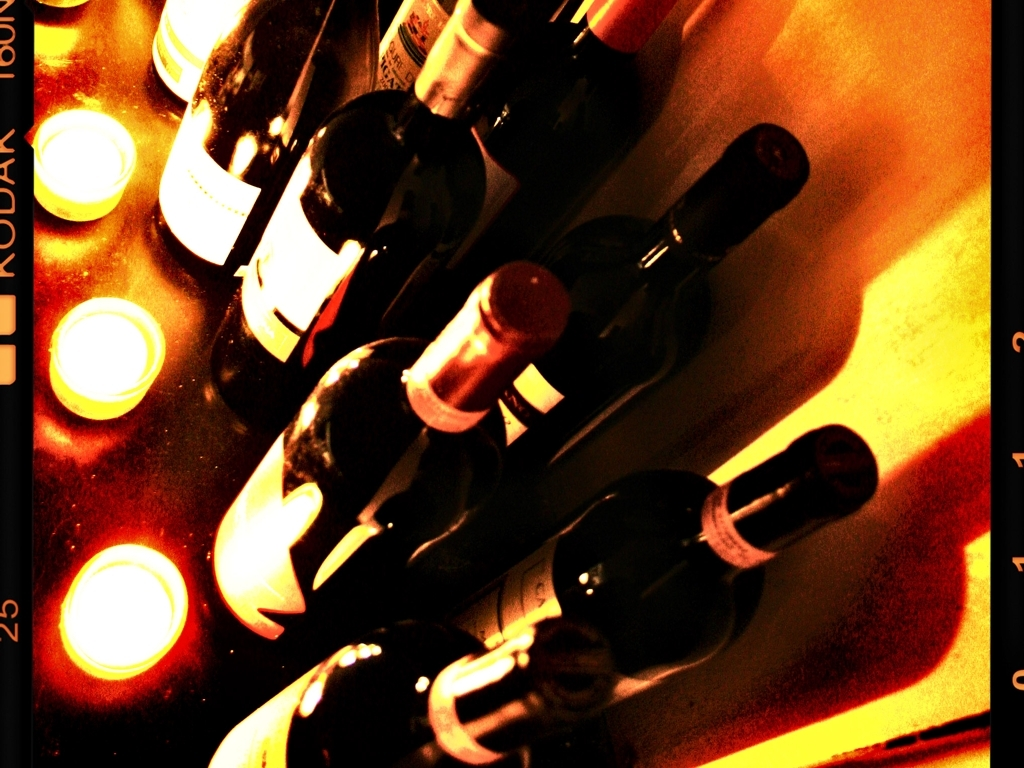What mood or atmosphere does the image evoke? The warm tones and soft lighting of the image, combined with the bottles of wine, convey a cozy and intimate ambiance. It suggests a setting where one might wind down and enjoy a relaxing evening. The overexposure of the lights adds a dreamy, almost nostalgic quality to the scene. 